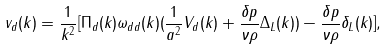<formula> <loc_0><loc_0><loc_500><loc_500>v _ { d } ( k ) = \frac { 1 } { k ^ { 2 } } [ \Pi _ { d } ( k ) \omega _ { d d } ( k ) ( \frac { 1 } { a ^ { 2 } } V _ { d } ( k ) + \frac { \delta p } { \nu \rho } \Delta _ { L } ( k ) ) - \frac { \delta p } { \nu \rho } \delta _ { L } ( k ) ] ,</formula> 